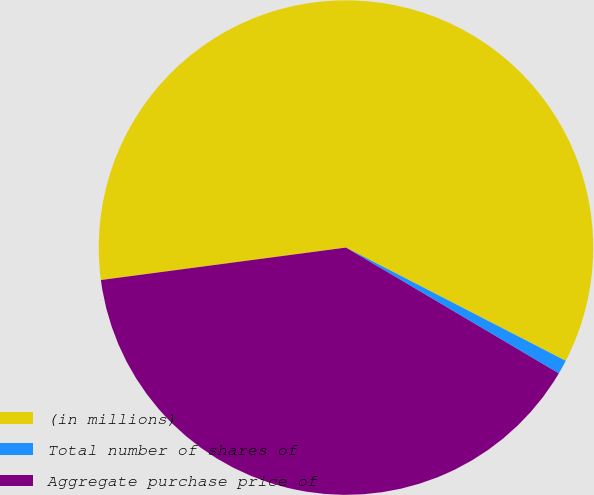Convert chart. <chart><loc_0><loc_0><loc_500><loc_500><pie_chart><fcel>(in millions)<fcel>Total number of shares of<fcel>Aggregate purchase price of<nl><fcel>59.67%<fcel>0.92%<fcel>39.41%<nl></chart> 